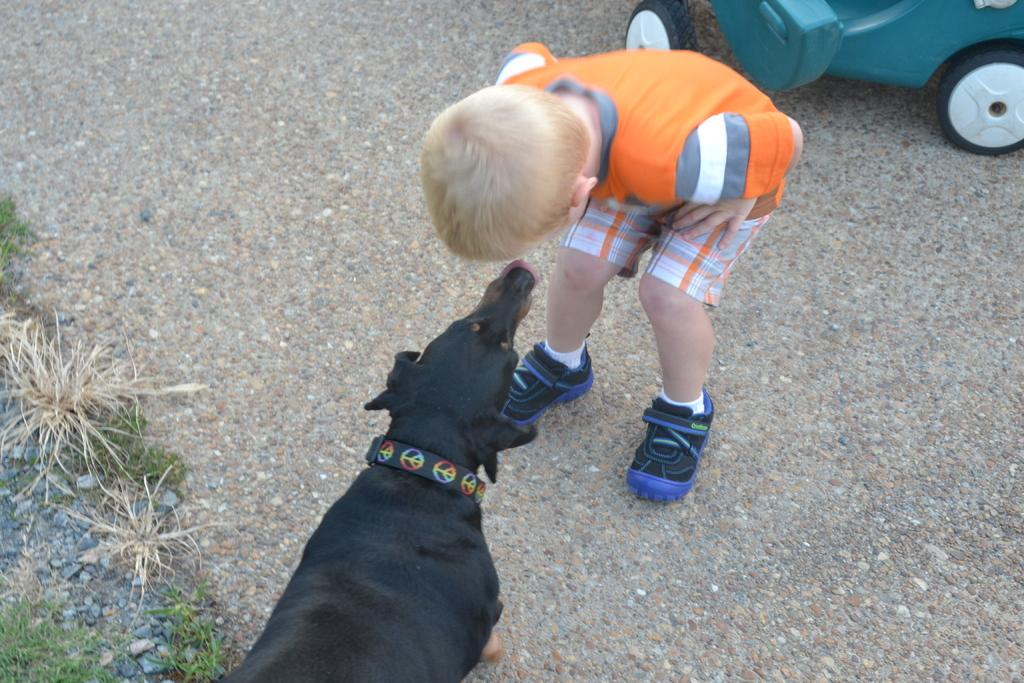Who is the main subject in the image? There is a boy in the image. What is the boy doing in the image? The boy is playing with a dog. What type of clothing is the boy wearing on his feet? The boy is wearing shoes. What type of clothing is the boy wearing on his lower body? The boy is wearing shorts. Can you describe anything else visible on the left side of the image? There is a short on the left side of the image, possibly another person wearing shorts. What type of skate is the boy using to perform a motion in the image? There is no skate present in the image; the boy is playing with a dog. What type of voyage is the boy embarking on in the image? There is no indication of a voyage in the image; the boy is simply playing with a dog. 